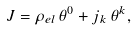<formula> <loc_0><loc_0><loc_500><loc_500>J = \rho _ { e l } \, \theta ^ { 0 } + j _ { k } \, \theta ^ { k } ,</formula> 